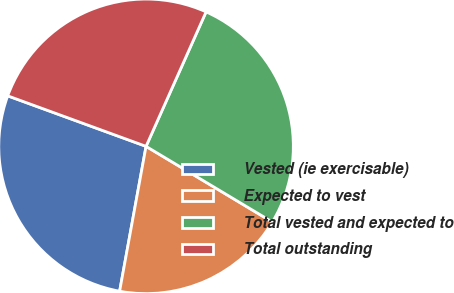Convert chart. <chart><loc_0><loc_0><loc_500><loc_500><pie_chart><fcel>Vested (ie exercisable)<fcel>Expected to vest<fcel>Total vested and expected to<fcel>Total outstanding<nl><fcel>27.7%<fcel>19.28%<fcel>26.91%<fcel>26.11%<nl></chart> 